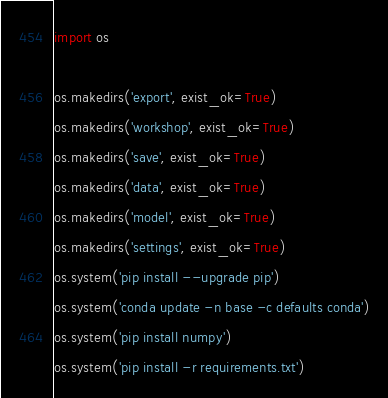<code> <loc_0><loc_0><loc_500><loc_500><_Python_>import os

os.makedirs('export', exist_ok=True)
os.makedirs('workshop', exist_ok=True)
os.makedirs('save', exist_ok=True)
os.makedirs('data', exist_ok=True)
os.makedirs('model', exist_ok=True)
os.makedirs('settings', exist_ok=True)
os.system('pip install --upgrade pip')
os.system('conda update -n base -c defaults conda')
os.system('pip install numpy')
os.system('pip install -r requirements.txt')
</code> 